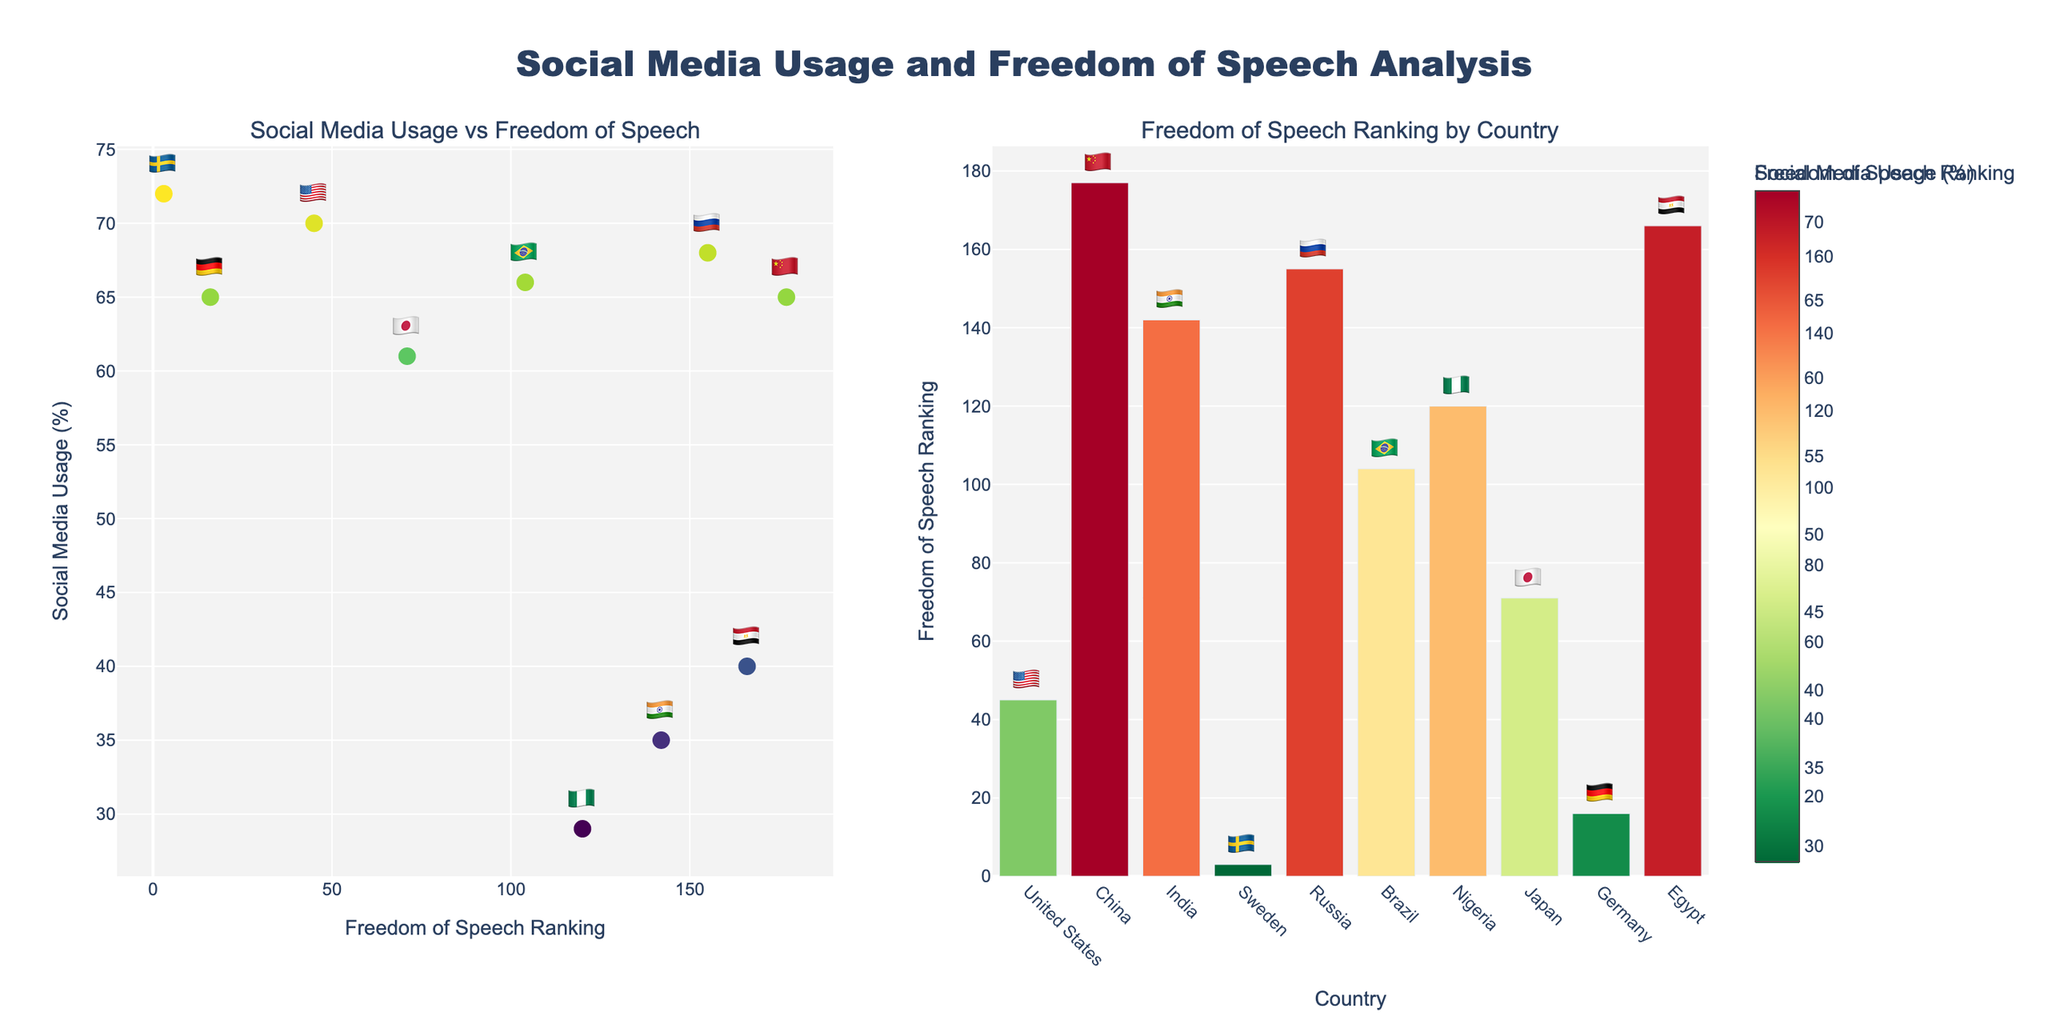What's the title of the overall figure? The title of the figure is typically found at the top of the chart. By reading the top of the plot, we can see the title clearly displayed.
Answer: Social Media Usage and Freedom of Speech Analysis Which country has the highest social media usage? To determine the country with the highest social media usage, examine the scatter plot's y-axis, which represents social media usage, and look for the point with the highest y-value.
Answer: 🇸🇪 (Sweden) How does the United States rank for freedom of speech? Locate the United States data point in the scatter plot and refer to the x-position to determine its Freedom of Speech Ranking.
Answer: 45 What is the relationship between social media usage and freedom of speech for China and Sweden? Compare the positions of China and Sweden on the scatter plot. China has lower freedom of speech ranking (177) and relatively high social media usage (65%). Sweden has high freedom of speech ranking (3) and the highest social media usage (72%).
Answer: China has high social media usage and low freedom of speech. Sweden has high social media usage and high freedom of speech Which country is ranked third for freedom of speech, and what's their social media usage? Find the country ranked 3rd on the bar chart on the right. Look for that country's social media usage on the scatter plot.
Answer: 🇸🇪 (Sweden), 72% What is the average social media usage of the countries ranked in the top 10 for freedom of speech in this figure? Identify the countries in the top 10 ranks for freedom of speech from the bar chart. Only Sweden (rank 3) is within the top 10. Therefore, the average is the social media usage of Sweden.
Answer: 72% Which country has a lower social media usage: Russia or Japan? Compare the social media usage of Russia and Japan by examining their respective points on the scatter plot.
Answer: Japan (61%) What's the social media usage in Germany, and how does it compare to Nigeria's? Find the social media usage percentages for Germany and Nigeria from the scatter plot. Germany has 65% usage, whereas Nigeria has 29%.
Answer: Germany has 65%, which is higher than Nigeria's 29% What pattern do you observe between high social media usage and freedom of speech? Visually inspect the scatter plot to identify any patterns or trends. High social media usage tends to correspond with higher freedom of speech rankings (lower numerical rankings), as seen with Sweden and Germany.
Answer: There is a tendency for countries with high social media usage to have higher freedom of speech rankings Which country has the closest freedom of speech ranking to Brazil, and what's their social media usage? Identify Brazil's freedom of speech ranking, then find the country with the closest ranking by looking at the x-axis. Brazil is at 104; the closest is Nigeria at 120.
Answer: Nigeria, 29% 